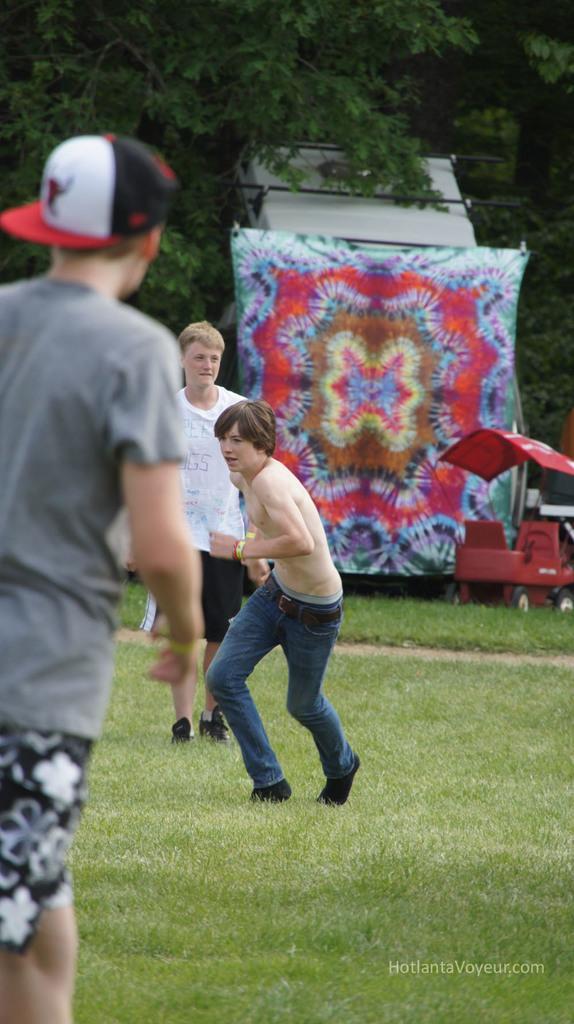Can you describe this image briefly? In this picture we can see a few people and some grass on the ground. We can see some objects and trees in the background. There is some text visible in the bottom right. 